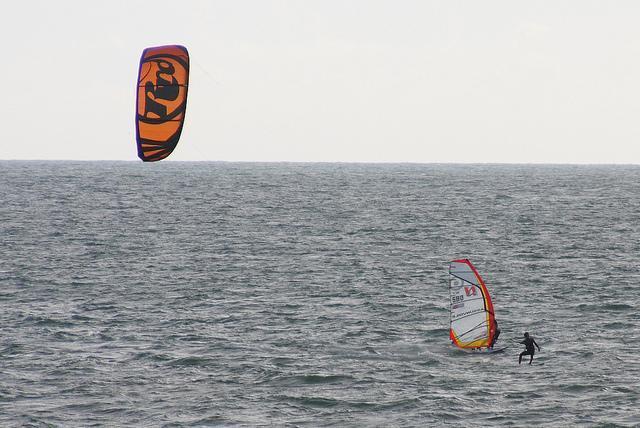How many black horse ?
Give a very brief answer. 0. 